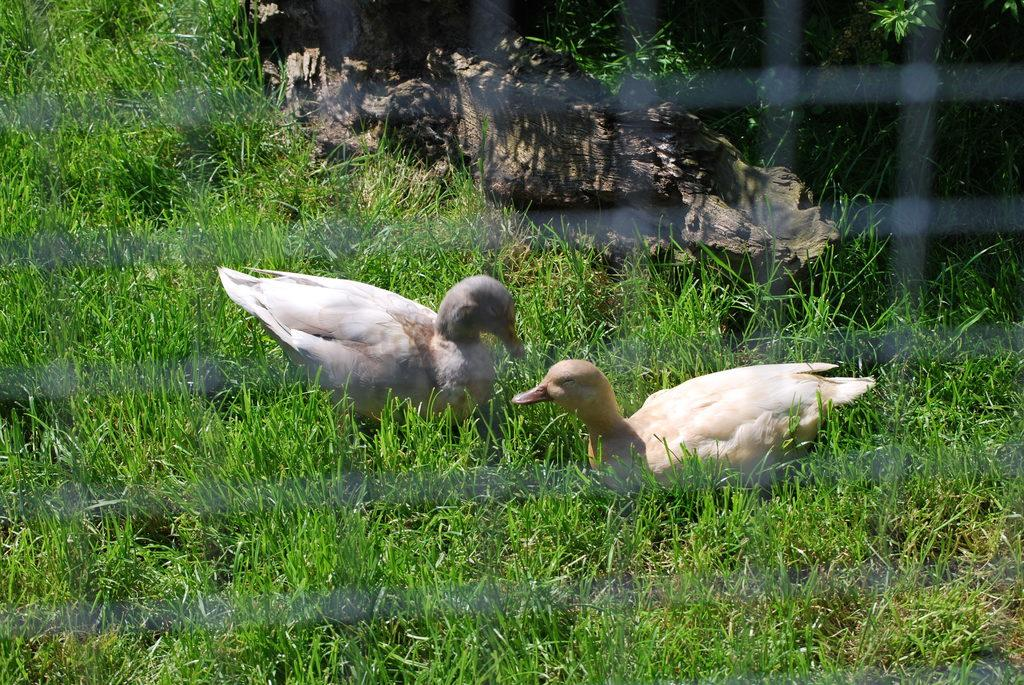How many birds are present in the image? There are two birds in the image. What are the birds standing on? The birds are standing on the grass. Can you describe any other objects in the image? Yes, there is a wooden piece in the image. What type of chalk is being used by the birds in the image? There is no chalk present in the image, and the birds are not using any chalk. How does the wind affect the birds in the image? There is no mention of wind in the image, and its effect on the birds cannot be determined. 